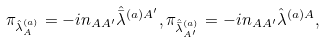Convert formula to latex. <formula><loc_0><loc_0><loc_500><loc_500>\pi _ { \hat { \lambda } ^ { ( a ) } _ { A } } = - i n _ { A A ^ { \prime } } \hat { \bar { \lambda } } ^ { ( a ) A ^ { \prime } } , \pi _ { \hat { \bar { \lambda } } ^ { ( a ) } _ { A ^ { \prime } } } = - i n _ { A A ^ { \prime } } \hat { \lambda } ^ { ( a ) A } ,</formula> 